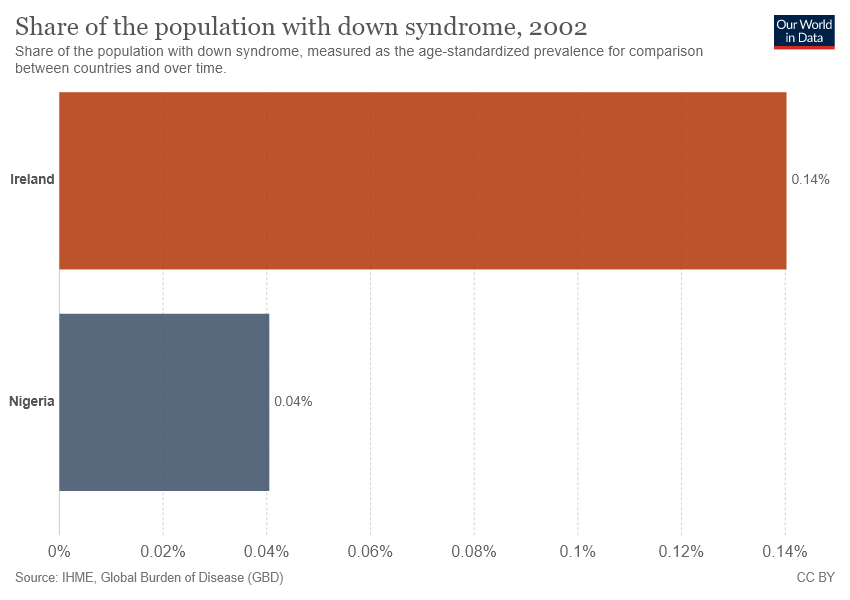Give some essential details in this illustration. Nigeria has the smallest bar. The average of Nigeria and Ireland is 0.09. 